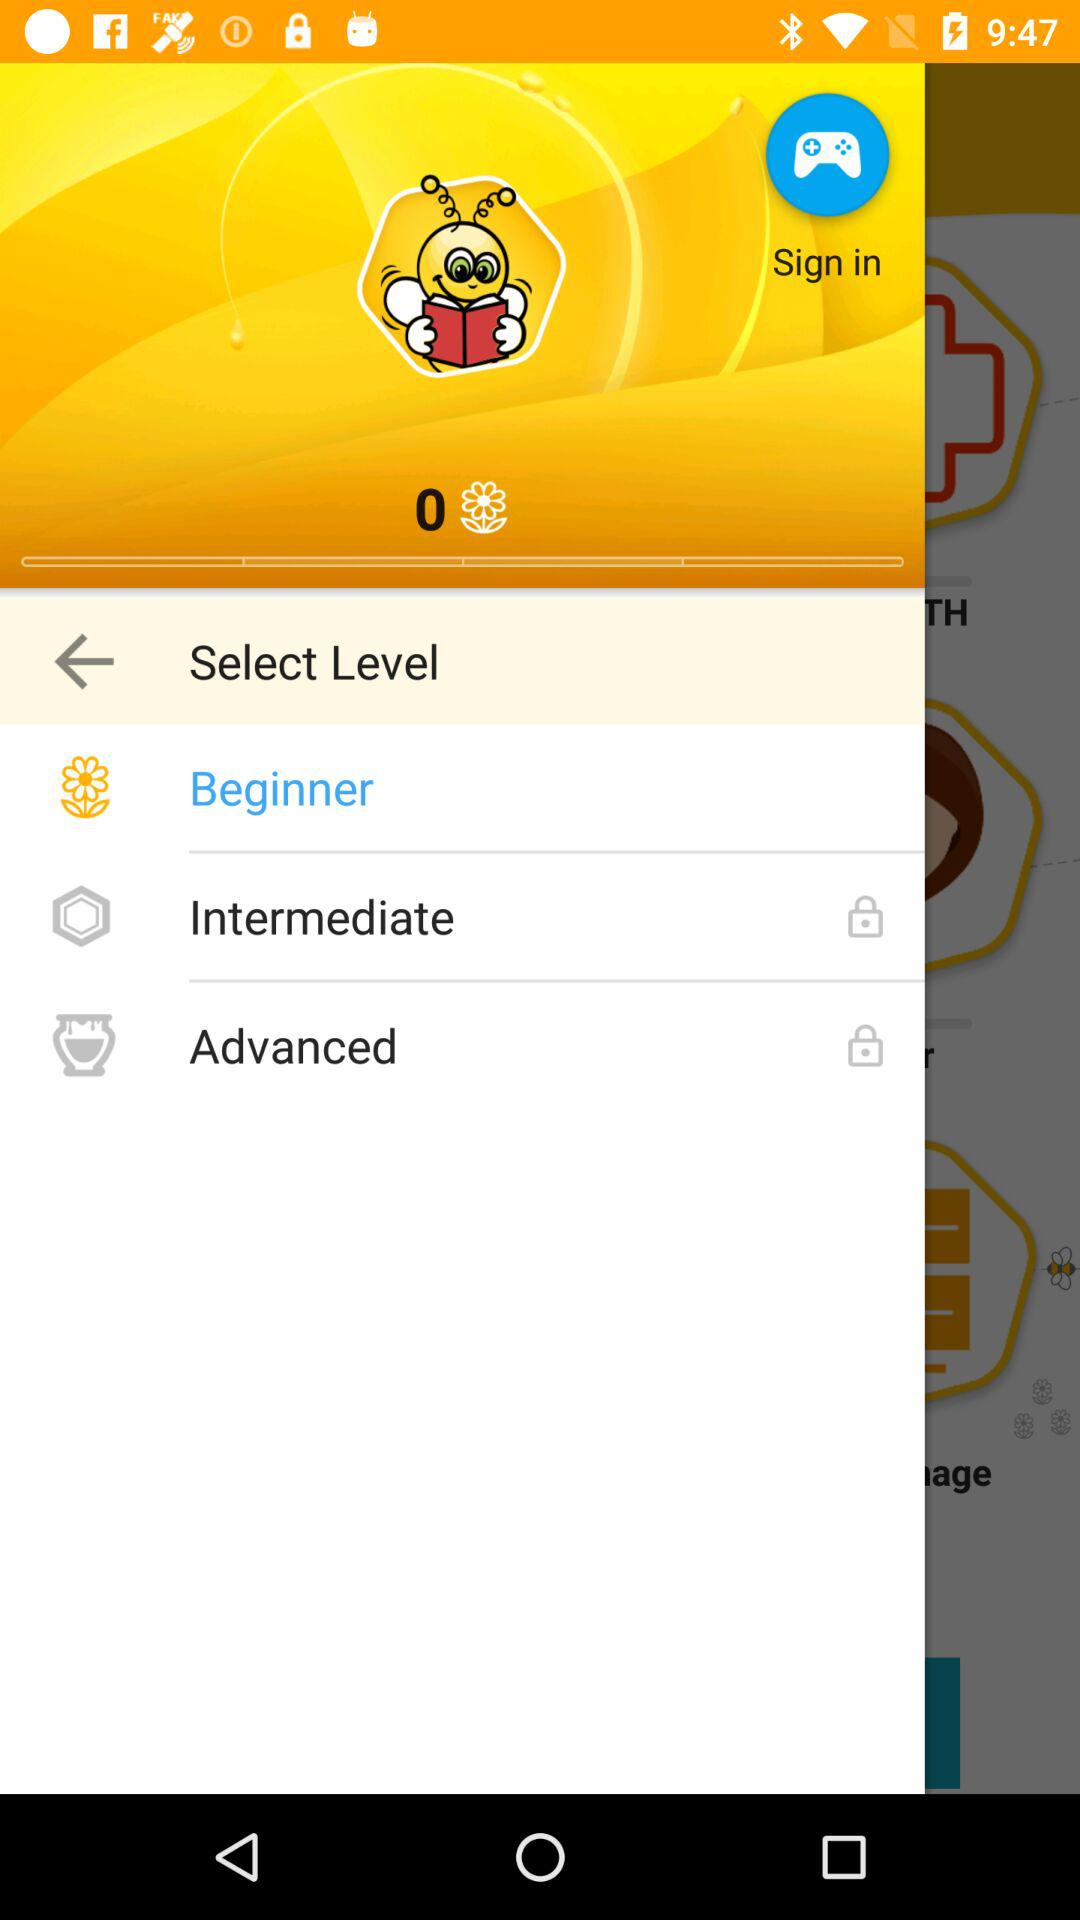How many levels are there in the game?
Answer the question using a single word or phrase. 3 